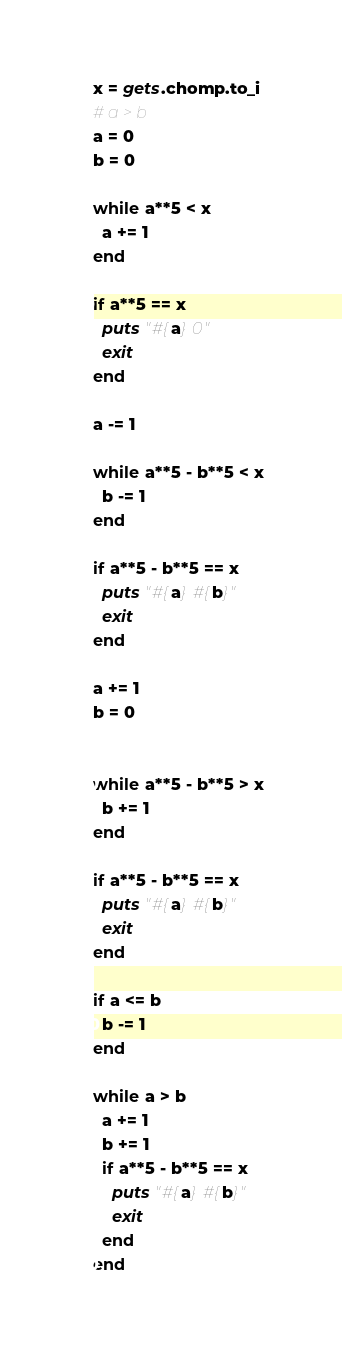<code> <loc_0><loc_0><loc_500><loc_500><_Ruby_>x = gets.chomp.to_i
# a > b
a = 0
b = 0

while a**5 < x
  a += 1
end

if a**5 == x
  puts "#{a} 0"
  exit
end

a -= 1

while a**5 - b**5 < x
  b -= 1
end

if a**5 - b**5 == x
  puts "#{a} #{b}"
  exit
end

a += 1
b = 0


while a**5 - b**5 > x
  b += 1
end

if a**5 - b**5 == x
  puts "#{a} #{b}"
  exit
end

if a <= b
  b -= 1
end

while a > b
  a += 1
  b += 1
  if a**5 - b**5 == x
    puts "#{a} #{b}"
    exit
  end
end
</code> 